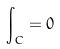<formula> <loc_0><loc_0><loc_500><loc_500>\int _ { C } = 0</formula> 